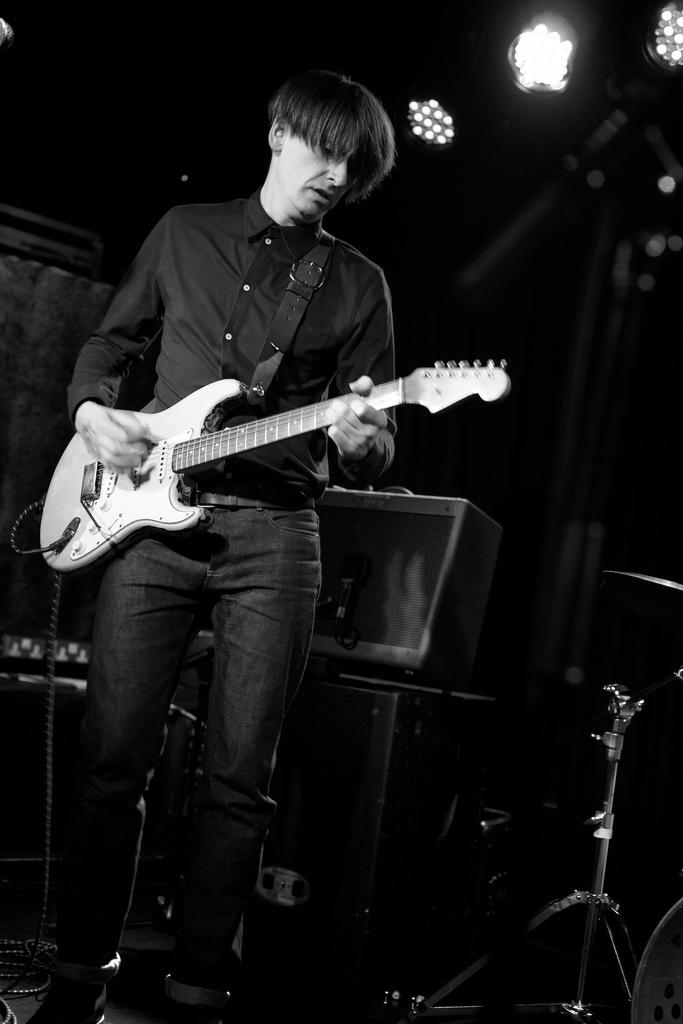Who is present in the image? There is a man in the image. What is the man holding in the image? The man is holding a guitar. What can be seen in the background of the image? There is a television in the background of the image. Can you describe the lighting in the image? There is a light at the top of the image. What type of wine is the man drinking in the image? There is no wine present in the image; the man is holding a guitar. 